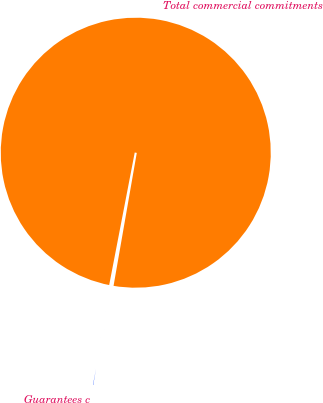Convert chart. <chart><loc_0><loc_0><loc_500><loc_500><pie_chart><fcel>Guarantees c<fcel>Total commercial commitments<nl><fcel>0.28%<fcel>99.72%<nl></chart> 